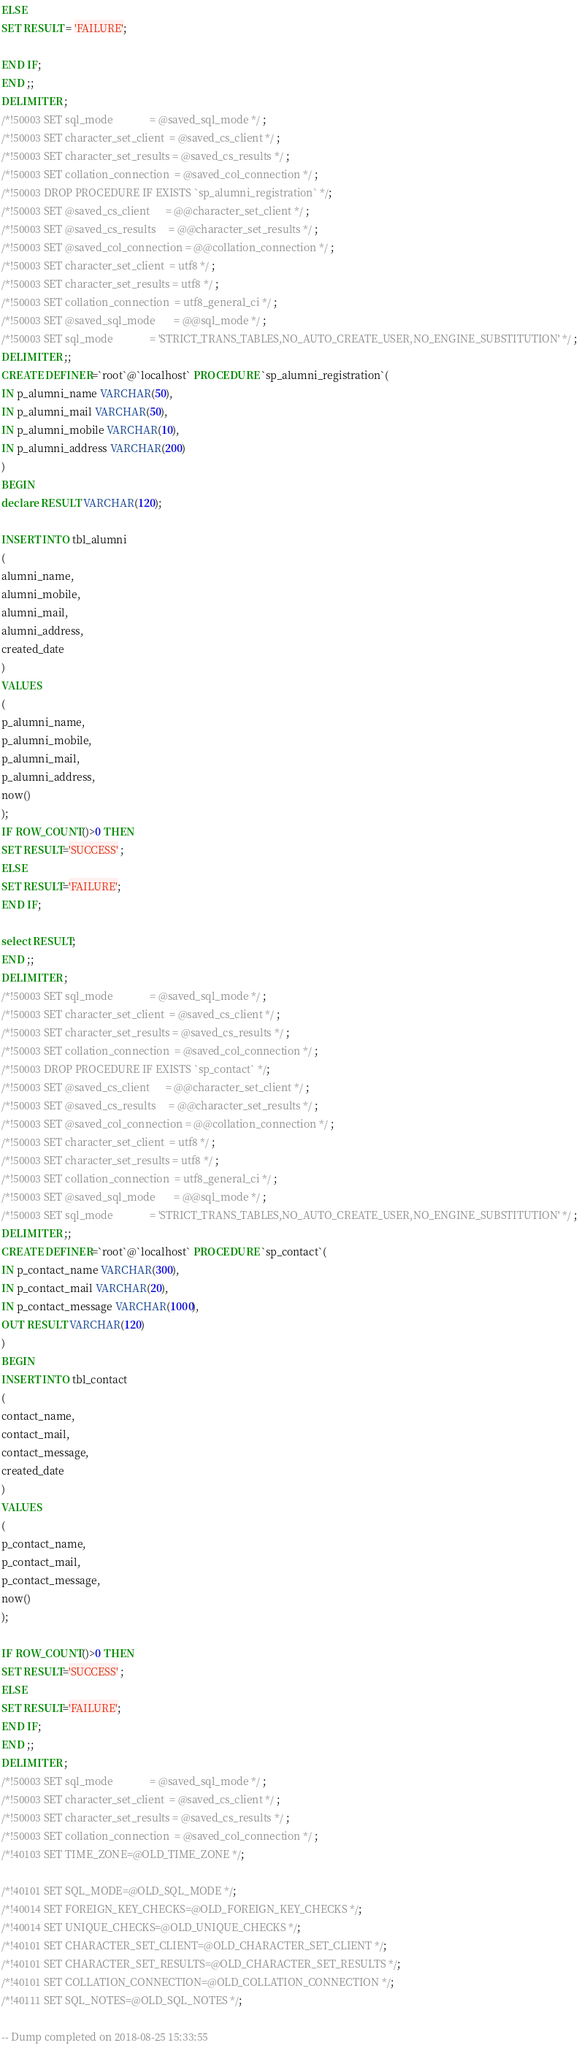<code> <loc_0><loc_0><loc_500><loc_500><_SQL_>ELSE
SET RESULT = 'FAILURE';

END IF;
END ;;
DELIMITER ;
/*!50003 SET sql_mode              = @saved_sql_mode */ ;
/*!50003 SET character_set_client  = @saved_cs_client */ ;
/*!50003 SET character_set_results = @saved_cs_results */ ;
/*!50003 SET collation_connection  = @saved_col_connection */ ;
/*!50003 DROP PROCEDURE IF EXISTS `sp_alumni_registration` */;
/*!50003 SET @saved_cs_client      = @@character_set_client */ ;
/*!50003 SET @saved_cs_results     = @@character_set_results */ ;
/*!50003 SET @saved_col_connection = @@collation_connection */ ;
/*!50003 SET character_set_client  = utf8 */ ;
/*!50003 SET character_set_results = utf8 */ ;
/*!50003 SET collation_connection  = utf8_general_ci */ ;
/*!50003 SET @saved_sql_mode       = @@sql_mode */ ;
/*!50003 SET sql_mode              = 'STRICT_TRANS_TABLES,NO_AUTO_CREATE_USER,NO_ENGINE_SUBSTITUTION' */ ;
DELIMITER ;;
CREATE DEFINER=`root`@`localhost` PROCEDURE `sp_alumni_registration`(
IN p_alumni_name VARCHAR(50),
IN p_alumni_mail VARCHAR(50),
IN p_alumni_mobile VARCHAR(10),
IN p_alumni_address VARCHAR(200)
)
BEGIN
declare RESULT VARCHAR(120);

INSERT INTO tbl_alumni
(
alumni_name,
alumni_mobile,
alumni_mail,
alumni_address,
created_date
) 
VALUES 
(
p_alumni_name,
p_alumni_mobile,
p_alumni_mail,
p_alumni_address,
now()
);
IF ROW_COUNT()>0 THEN
SET RESULT='SUCCESS' ;
ELSE 
SET RESULT='FAILURE';
END IF;

select RESULT;
END ;;
DELIMITER ;
/*!50003 SET sql_mode              = @saved_sql_mode */ ;
/*!50003 SET character_set_client  = @saved_cs_client */ ;
/*!50003 SET character_set_results = @saved_cs_results */ ;
/*!50003 SET collation_connection  = @saved_col_connection */ ;
/*!50003 DROP PROCEDURE IF EXISTS `sp_contact` */;
/*!50003 SET @saved_cs_client      = @@character_set_client */ ;
/*!50003 SET @saved_cs_results     = @@character_set_results */ ;
/*!50003 SET @saved_col_connection = @@collation_connection */ ;
/*!50003 SET character_set_client  = utf8 */ ;
/*!50003 SET character_set_results = utf8 */ ;
/*!50003 SET collation_connection  = utf8_general_ci */ ;
/*!50003 SET @saved_sql_mode       = @@sql_mode */ ;
/*!50003 SET sql_mode              = 'STRICT_TRANS_TABLES,NO_AUTO_CREATE_USER,NO_ENGINE_SUBSTITUTION' */ ;
DELIMITER ;;
CREATE DEFINER=`root`@`localhost` PROCEDURE `sp_contact`(
IN p_contact_name VARCHAR(300),
IN p_contact_mail VARCHAR(20),
IN p_contact_message VARCHAR(1000),
OUT RESULT VARCHAR(120)
)
BEGIN
INSERT INTO tbl_contact
(
contact_name,
contact_mail,
contact_message,
created_date
) 
VALUES 
(
p_contact_name,
p_contact_mail,
p_contact_message,
now()
);

IF ROW_COUNT()>0 THEN
SET RESULT='SUCCESS' ;
ELSE 
SET RESULT='FAILURE';
END IF;
END ;;
DELIMITER ;
/*!50003 SET sql_mode              = @saved_sql_mode */ ;
/*!50003 SET character_set_client  = @saved_cs_client */ ;
/*!50003 SET character_set_results = @saved_cs_results */ ;
/*!50003 SET collation_connection  = @saved_col_connection */ ;
/*!40103 SET TIME_ZONE=@OLD_TIME_ZONE */;

/*!40101 SET SQL_MODE=@OLD_SQL_MODE */;
/*!40014 SET FOREIGN_KEY_CHECKS=@OLD_FOREIGN_KEY_CHECKS */;
/*!40014 SET UNIQUE_CHECKS=@OLD_UNIQUE_CHECKS */;
/*!40101 SET CHARACTER_SET_CLIENT=@OLD_CHARACTER_SET_CLIENT */;
/*!40101 SET CHARACTER_SET_RESULTS=@OLD_CHARACTER_SET_RESULTS */;
/*!40101 SET COLLATION_CONNECTION=@OLD_COLLATION_CONNECTION */;
/*!40111 SET SQL_NOTES=@OLD_SQL_NOTES */;

-- Dump completed on 2018-08-25 15:33:55
</code> 